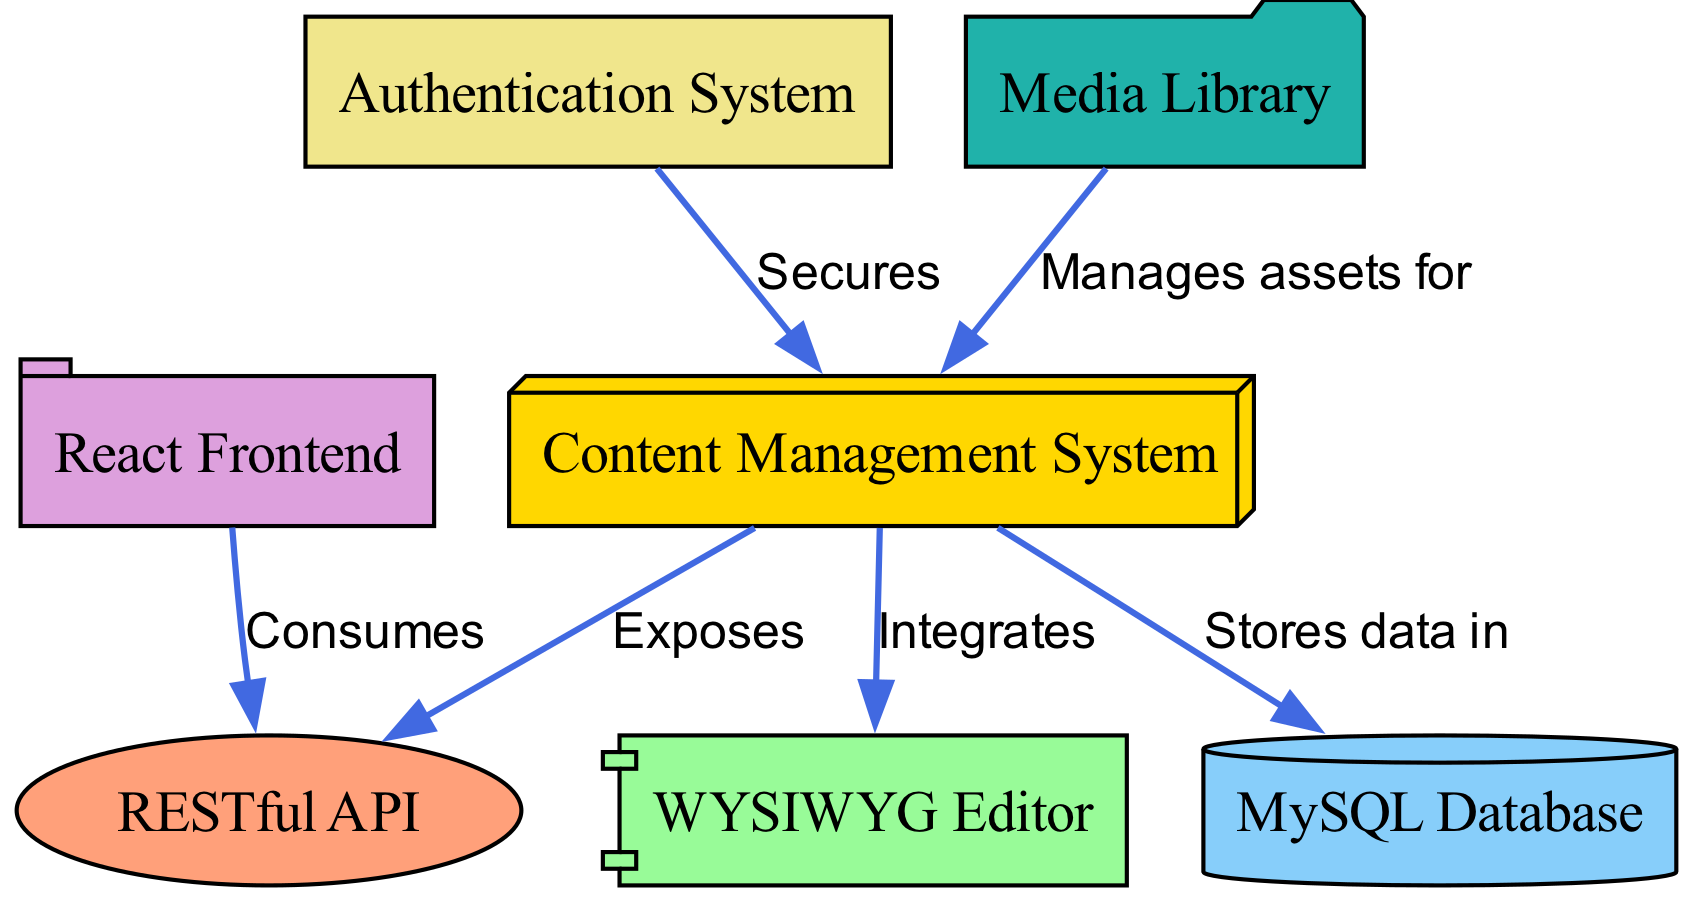What is the node labeled "cms"? The node labeled "cms" represents the Content Management System, which is a central component in the architecture described in the diagram.
Answer: Content Management System How many nodes are present in the diagram? By counting the unique elements listed in the nodes section of the diagram data, there are a total of seven distinct nodes present.
Answer: 7 What shape represents the "database" node? The "database" node is represented in the diagram as a cylinder, which is a visual convention used to denote database components in architectural diagrams.
Answer: Cylinder Which node manages assets for the "cms"? The "media" node is specified in the diagram as the component that manages assets for the Content Management System, indicating its role in handling multimedia content.
Answer: Media Library What relationship exists between "frontend" and "api"? The diagram indicates that the "frontend" consumes the "api," meaning that the frontend application retrieves or sends data through the API for rendering or performing actions in the blogging platform.
Answer: Consumes How does the "auth" node interact with the "cms"? The "auth" node secures the "cms," indicating that authentication processes are applied to protect the Content Management System, ensuring that only authorized users can access various functionalities.
Answer: Secures What component does the "WYSIWYG Editor" integrate with? The "WYSIWYG Editor" node integrates with the "cms," serving as a user-friendly interface for content creation and editing within the Content Management System.
Answer: Integrates How many edges are present in the diagram? By counting the relationships listed in the edges section, there are a total of six connections (edges) that depict interactions among the various components outlined in the diagram.
Answer: 6 Which node is directly exposed by the "cms"? According to the diagram, the "cms" exposes the "api," meaning the Content Management System provides a set of endpoints for the frontend and other services to interact with the underlying data and functionality.
Answer: RESTful API 